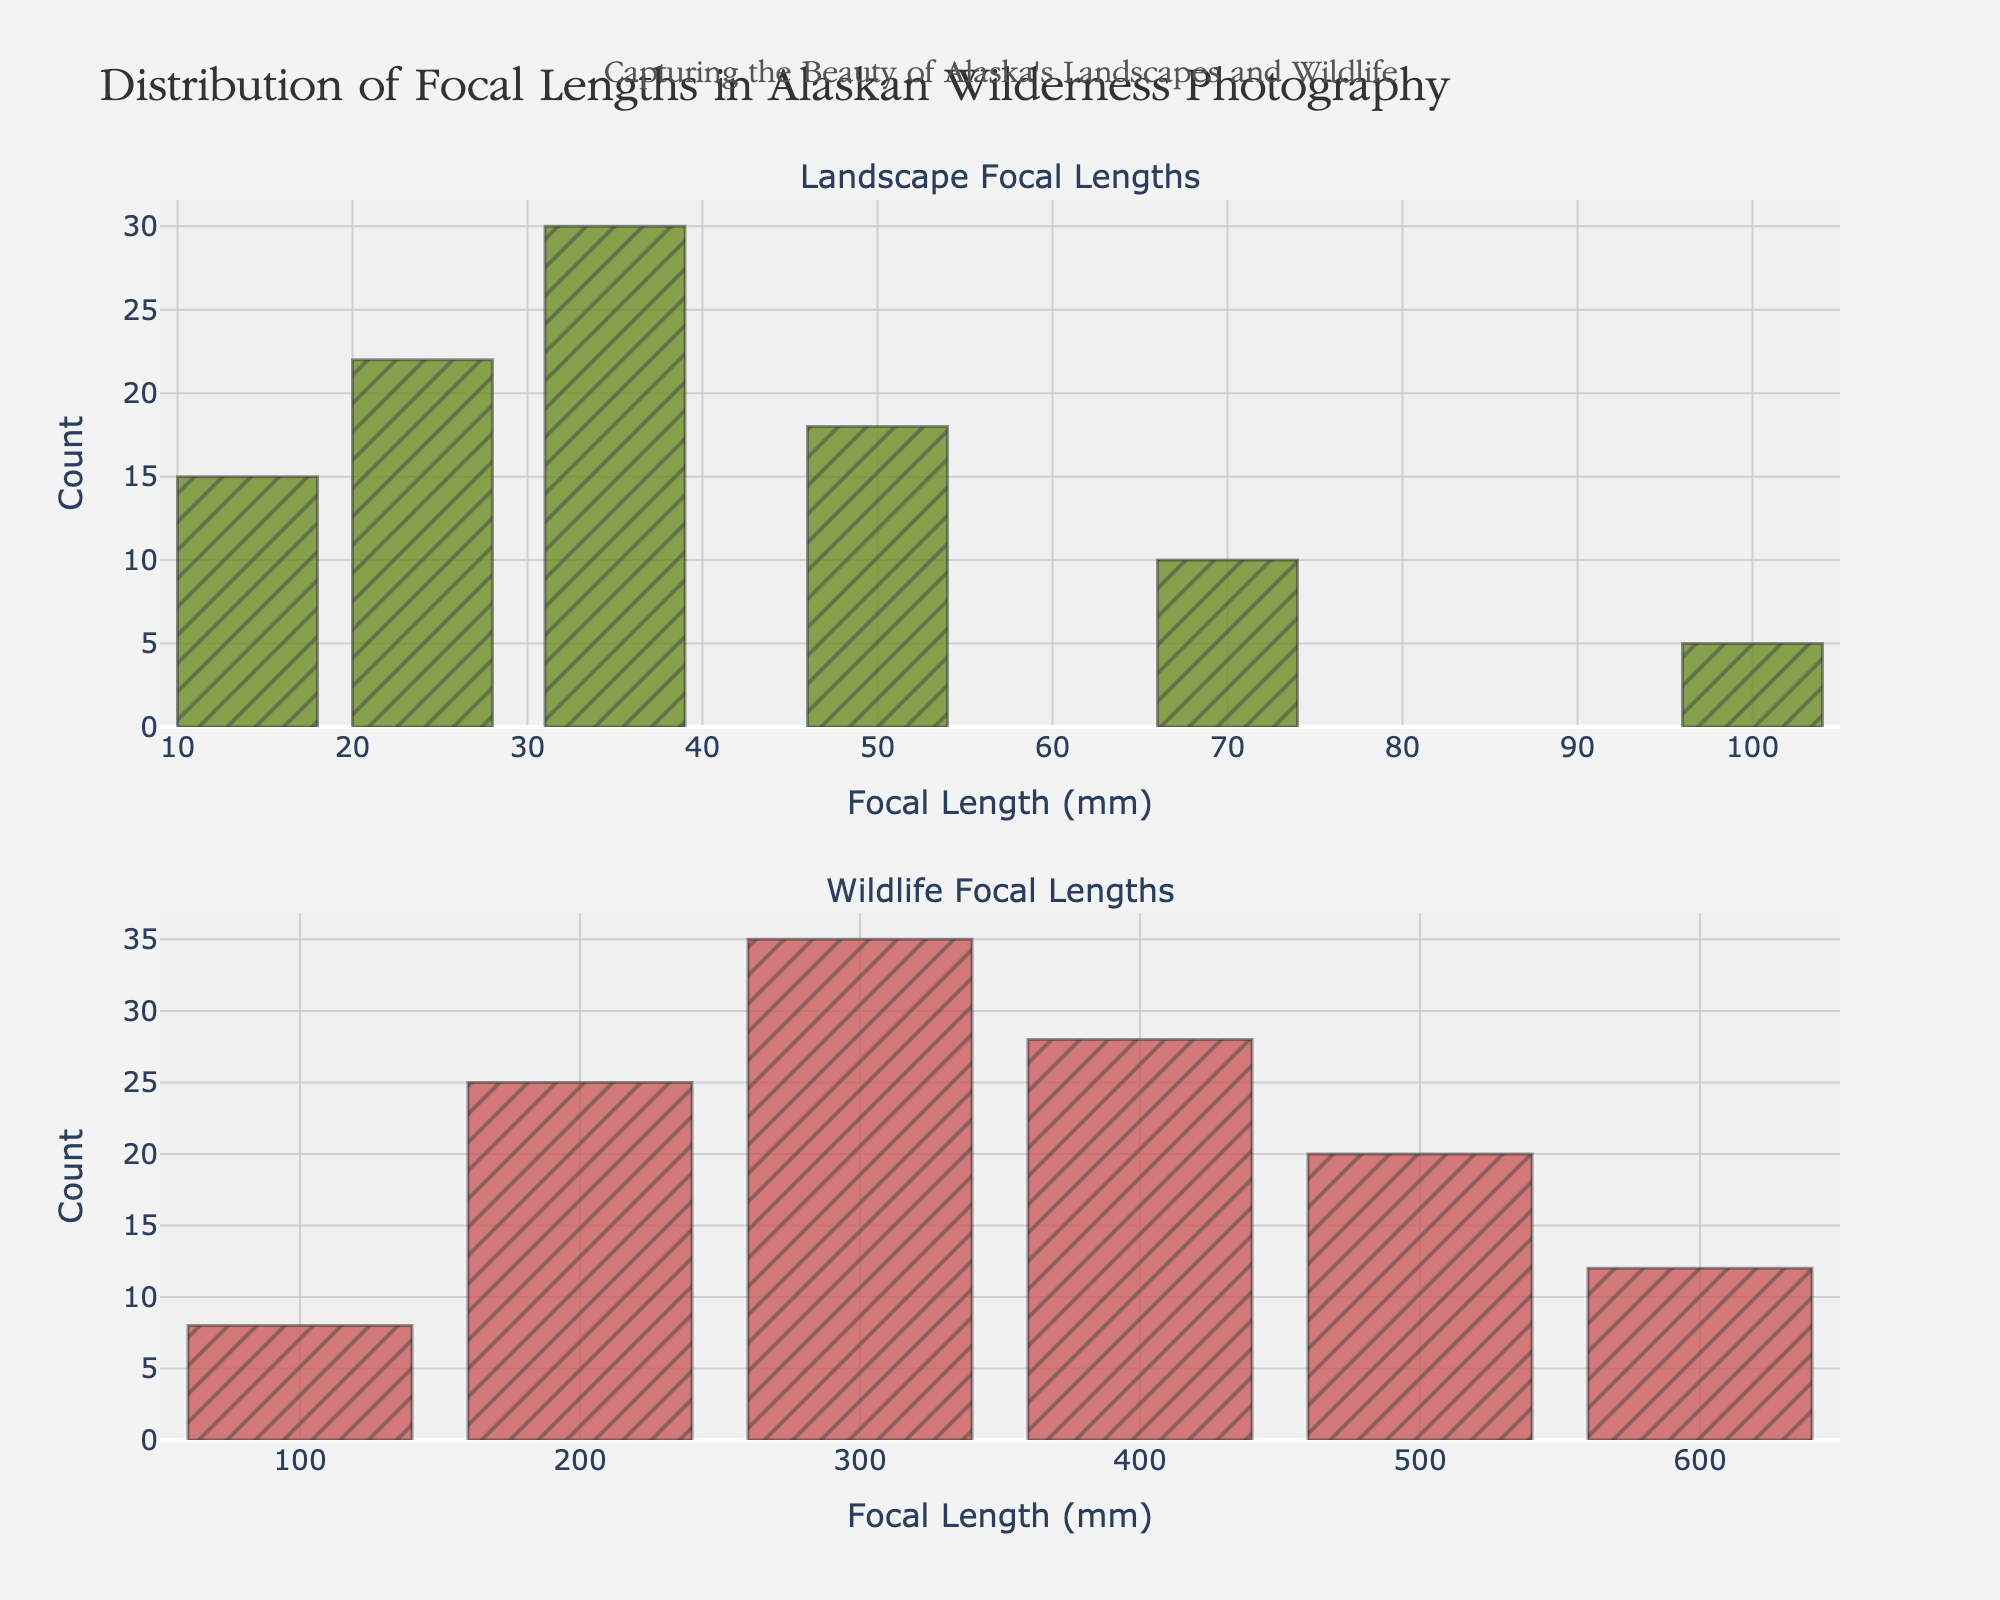What is the title of the figure? The title is prominently displayed at the top of the figure.
Answer: Distribution of Focal Lengths in Alaskan Wilderness Photography What focal length has the highest count in the Landscape category? The count for each focal length in the Landscape category is represented by the height of the bars. The tallest bar indicates the highest count.
Answer: 35 mm Which focal length is most used in Wildlife photography? The count for each focal length in the Wildlife category is represented by the height of the bars. The tallest bar indicates the highest count.
Answer: 300 mm How many focal lengths are used in the Landscape category? Count the number of different focal length bars in the Landscape subplot.
Answer: 6 What is the count for the 500 mm focal length in the Wildlife category? Locate the bar corresponding to 500 mm in the Wildlife subplot and read its height.
Answer: 20 Which category, Landscape or Wildlife, has a higher usage of 100 mm lenses? Compare the heights of the bars for 100 mm in both subplots.
Answer: Landscape What is the combined count of 24 mm and 50 mm focal lengths in the Landscape category? Add the counts for 24 mm and 50 mm bars in the Landscape subplot: 22 + 18.
Answer: 40 Which focal length has the biggest difference in count between Landscape and Wildlife categories? Calculate the difference in counts for each focal length present in both categories, and identify the focal length with the maximum difference.
Answer: 300 mm By how much does the count for 300 mm exceed the count for 200 mm in the Wildlife category? Subtract the count for 200 mm from the count for 300 mm in the Wildlife subplot: 35 - 25.
Answer: 10 What is the basic theme conveyed by the annotation in the figure? Read the text provided as the annotation above the subplots.
Answer: Capturing the Beauty of Alaska's Landscapes and Wildlife 